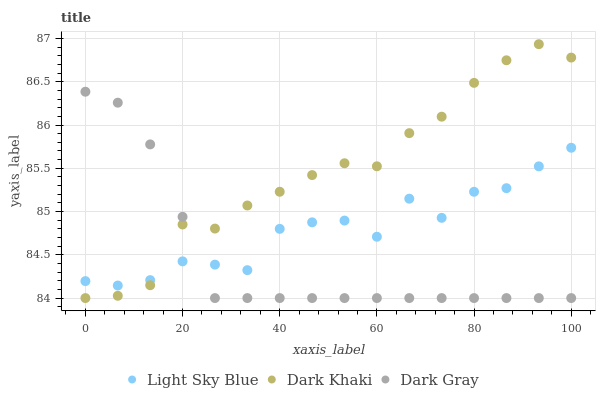Does Dark Gray have the minimum area under the curve?
Answer yes or no. Yes. Does Dark Khaki have the maximum area under the curve?
Answer yes or no. Yes. Does Light Sky Blue have the minimum area under the curve?
Answer yes or no. No. Does Light Sky Blue have the maximum area under the curve?
Answer yes or no. No. Is Dark Gray the smoothest?
Answer yes or no. Yes. Is Light Sky Blue the roughest?
Answer yes or no. Yes. Is Light Sky Blue the smoothest?
Answer yes or no. No. Is Dark Gray the roughest?
Answer yes or no. No. Does Dark Khaki have the lowest value?
Answer yes or no. Yes. Does Light Sky Blue have the lowest value?
Answer yes or no. No. Does Dark Khaki have the highest value?
Answer yes or no. Yes. Does Dark Gray have the highest value?
Answer yes or no. No. Does Dark Khaki intersect Dark Gray?
Answer yes or no. Yes. Is Dark Khaki less than Dark Gray?
Answer yes or no. No. Is Dark Khaki greater than Dark Gray?
Answer yes or no. No. 